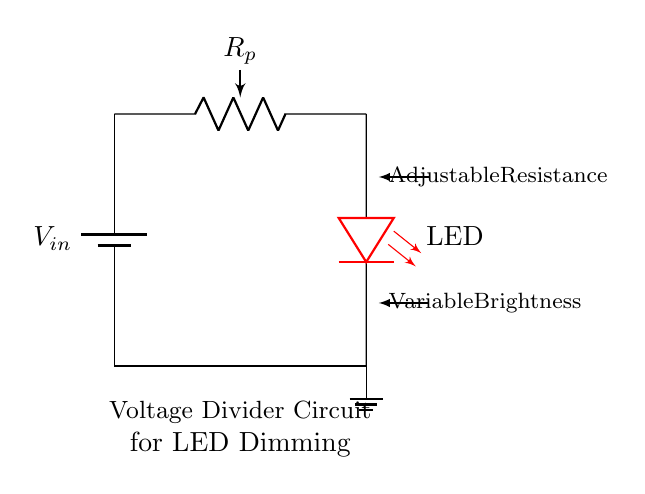What is the purpose of the potentiometer in this circuit? The potentiometer is used to adjust the resistance, which allows for variable brightness of the LED by changing the voltage across it.
Answer: Adjustable resistance What type of circuit is this? This is a voltage divider circuit, as it divides the input voltage through the resistive component.
Answer: Voltage divider What component is used to produce light in this circuit? The LED component is responsible for producing light when current flows through it.
Answer: LED What does adjusting the potentiometer do to the LED? Adjusting the potentiometer changes the voltage across the LED, which alters its brightness.
Answer: Variable brightness What is the relationship between the potentiometer and the LED in terms of current flow? The current flowing to the LED depends on the resistance set by the potentiometer, affecting how much current passes through the LED.
Answer: Sets current flow 